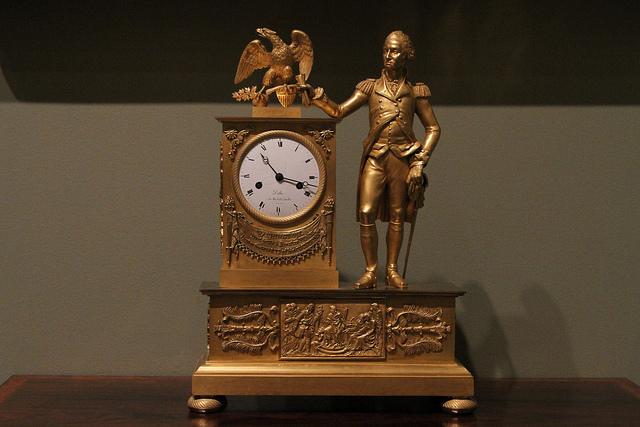Are these items on display?
Answer briefly. Yes. What kind of numerals are used on the clock?
Write a very short answer. Roman. What's the bird atop the clock?
Give a very brief answer. Eagle. What animal is depicted on this clock?
Keep it brief. Eagle. What animal are the knick knacks?
Answer briefly. Eagle. Is this a gilt antique?
Short answer required. Yes. 